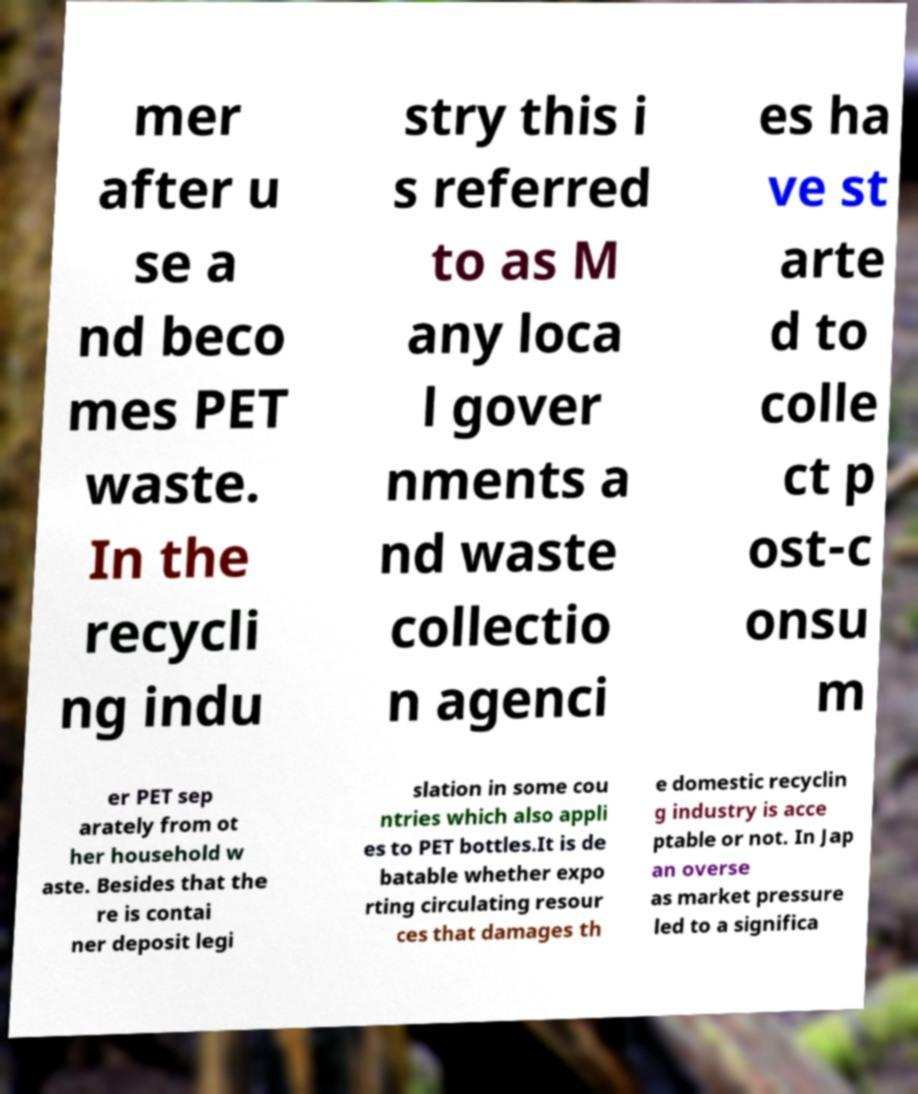Can you accurately transcribe the text from the provided image for me? mer after u se a nd beco mes PET waste. In the recycli ng indu stry this i s referred to as M any loca l gover nments a nd waste collectio n agenci es ha ve st arte d to colle ct p ost-c onsu m er PET sep arately from ot her household w aste. Besides that the re is contai ner deposit legi slation in some cou ntries which also appli es to PET bottles.It is de batable whether expo rting circulating resour ces that damages th e domestic recyclin g industry is acce ptable or not. In Jap an overse as market pressure led to a significa 